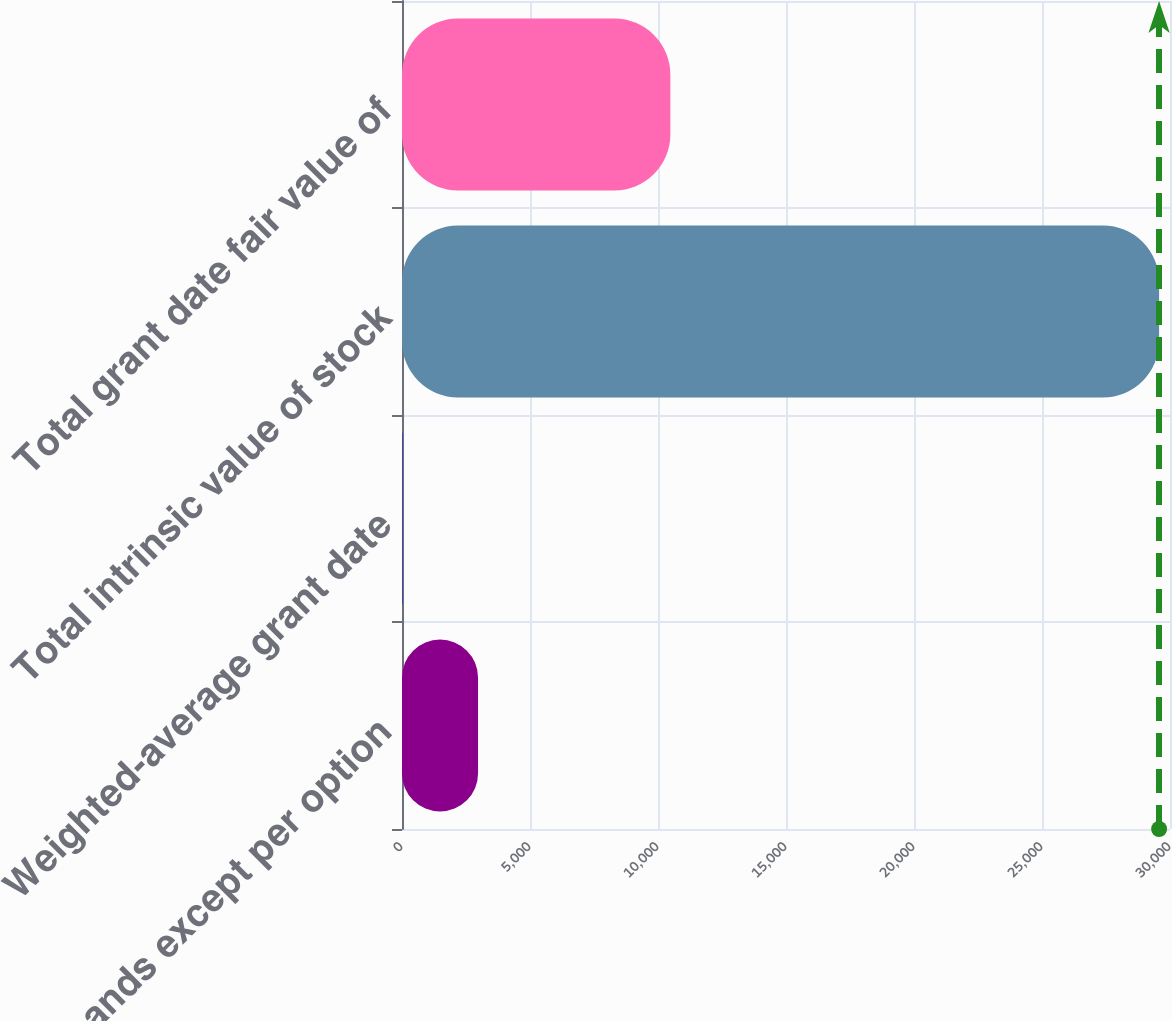<chart> <loc_0><loc_0><loc_500><loc_500><bar_chart><fcel>in thousands except per option<fcel>Weighted-average grant date<fcel>Total intrinsic value of stock<fcel>Total grant date fair value of<nl><fcel>2970.32<fcel>14.36<fcel>29574<fcel>10483<nl></chart> 